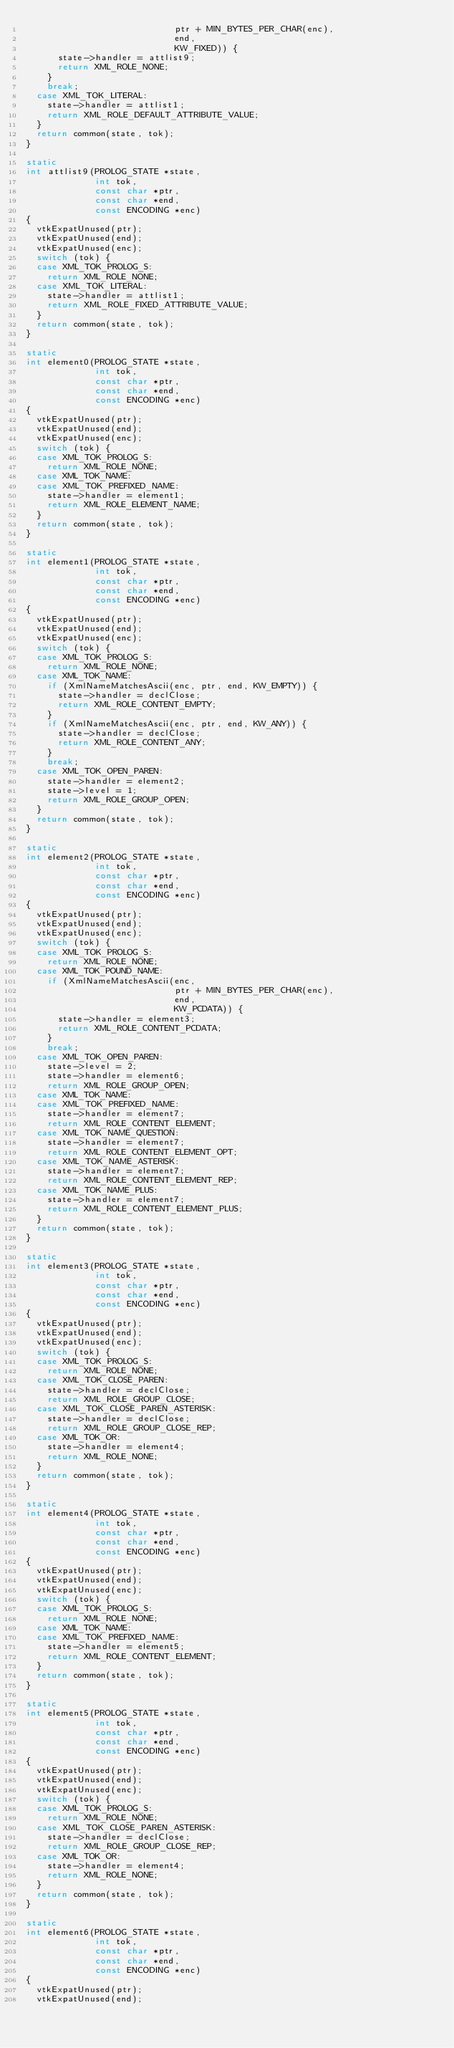<code> <loc_0><loc_0><loc_500><loc_500><_C_>                            ptr + MIN_BYTES_PER_CHAR(enc),
                            end,
                            KW_FIXED)) {
      state->handler = attlist9;
      return XML_ROLE_NONE;
    }
    break;
  case XML_TOK_LITERAL:
    state->handler = attlist1;
    return XML_ROLE_DEFAULT_ATTRIBUTE_VALUE;
  }
  return common(state, tok);
}

static
int attlist9(PROLOG_STATE *state,
             int tok,
             const char *ptr,
             const char *end,
             const ENCODING *enc)
{
  vtkExpatUnused(ptr);
  vtkExpatUnused(end);
  vtkExpatUnused(enc);
  switch (tok) {
  case XML_TOK_PROLOG_S:
    return XML_ROLE_NONE;
  case XML_TOK_LITERAL:
    state->handler = attlist1;
    return XML_ROLE_FIXED_ATTRIBUTE_VALUE;
  }
  return common(state, tok);
}

static
int element0(PROLOG_STATE *state,
             int tok,
             const char *ptr,
             const char *end,
             const ENCODING *enc)
{
  vtkExpatUnused(ptr);
  vtkExpatUnused(end);
  vtkExpatUnused(enc);
  switch (tok) {
  case XML_TOK_PROLOG_S:
    return XML_ROLE_NONE;
  case XML_TOK_NAME:
  case XML_TOK_PREFIXED_NAME:
    state->handler = element1;
    return XML_ROLE_ELEMENT_NAME;
  }
  return common(state, tok);
}

static
int element1(PROLOG_STATE *state,
             int tok,
             const char *ptr,
             const char *end,
             const ENCODING *enc)
{
  vtkExpatUnused(ptr);
  vtkExpatUnused(end);
  vtkExpatUnused(enc);
  switch (tok) {
  case XML_TOK_PROLOG_S:
    return XML_ROLE_NONE;
  case XML_TOK_NAME:
    if (XmlNameMatchesAscii(enc, ptr, end, KW_EMPTY)) {
      state->handler = declClose;
      return XML_ROLE_CONTENT_EMPTY;
    }
    if (XmlNameMatchesAscii(enc, ptr, end, KW_ANY)) {
      state->handler = declClose;
      return XML_ROLE_CONTENT_ANY;
    }
    break;
  case XML_TOK_OPEN_PAREN:
    state->handler = element2;
    state->level = 1;
    return XML_ROLE_GROUP_OPEN;
  }
  return common(state, tok);
}

static
int element2(PROLOG_STATE *state,
             int tok,
             const char *ptr,
             const char *end,
             const ENCODING *enc)
{
  vtkExpatUnused(ptr);
  vtkExpatUnused(end);
  vtkExpatUnused(enc);
  switch (tok) {
  case XML_TOK_PROLOG_S:
    return XML_ROLE_NONE;
  case XML_TOK_POUND_NAME:
    if (XmlNameMatchesAscii(enc,
                            ptr + MIN_BYTES_PER_CHAR(enc),
                            end,
                            KW_PCDATA)) {
      state->handler = element3;
      return XML_ROLE_CONTENT_PCDATA;
    }
    break;
  case XML_TOK_OPEN_PAREN:
    state->level = 2;
    state->handler = element6;
    return XML_ROLE_GROUP_OPEN;
  case XML_TOK_NAME:
  case XML_TOK_PREFIXED_NAME:
    state->handler = element7;
    return XML_ROLE_CONTENT_ELEMENT;
  case XML_TOK_NAME_QUESTION:
    state->handler = element7;
    return XML_ROLE_CONTENT_ELEMENT_OPT;
  case XML_TOK_NAME_ASTERISK:
    state->handler = element7;
    return XML_ROLE_CONTENT_ELEMENT_REP;
  case XML_TOK_NAME_PLUS:
    state->handler = element7;
    return XML_ROLE_CONTENT_ELEMENT_PLUS;
  }
  return common(state, tok);
}

static
int element3(PROLOG_STATE *state,
             int tok,
             const char *ptr,
             const char *end,
             const ENCODING *enc)
{
  vtkExpatUnused(ptr);
  vtkExpatUnused(end);
  vtkExpatUnused(enc);
  switch (tok) {
  case XML_TOK_PROLOG_S:
    return XML_ROLE_NONE;
  case XML_TOK_CLOSE_PAREN:
    state->handler = declClose;
    return XML_ROLE_GROUP_CLOSE;
  case XML_TOK_CLOSE_PAREN_ASTERISK:
    state->handler = declClose;
    return XML_ROLE_GROUP_CLOSE_REP;
  case XML_TOK_OR:
    state->handler = element4;
    return XML_ROLE_NONE;
  }
  return common(state, tok);
}

static
int element4(PROLOG_STATE *state,
             int tok,
             const char *ptr,
             const char *end,
             const ENCODING *enc)
{
  vtkExpatUnused(ptr);
  vtkExpatUnused(end);
  vtkExpatUnused(enc);
  switch (tok) {
  case XML_TOK_PROLOG_S:
    return XML_ROLE_NONE;
  case XML_TOK_NAME:
  case XML_TOK_PREFIXED_NAME:
    state->handler = element5;
    return XML_ROLE_CONTENT_ELEMENT;
  }
  return common(state, tok);
}

static
int element5(PROLOG_STATE *state,
             int tok,
             const char *ptr,
             const char *end,
             const ENCODING *enc)
{
  vtkExpatUnused(ptr);
  vtkExpatUnused(end);
  vtkExpatUnused(enc);
  switch (tok) {
  case XML_TOK_PROLOG_S:
    return XML_ROLE_NONE;
  case XML_TOK_CLOSE_PAREN_ASTERISK:
    state->handler = declClose;
    return XML_ROLE_GROUP_CLOSE_REP;
  case XML_TOK_OR:
    state->handler = element4;
    return XML_ROLE_NONE;
  }
  return common(state, tok);
}

static
int element6(PROLOG_STATE *state,
             int tok,
             const char *ptr,
             const char *end,
             const ENCODING *enc)
{
  vtkExpatUnused(ptr);
  vtkExpatUnused(end);</code> 